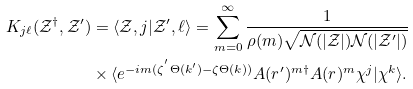<formula> <loc_0><loc_0><loc_500><loc_500>K _ { j \ell } ( \mathcal { Z } ^ { \dagger } , \mathcal { Z } ^ { \prime } ) & = \langle \mathcal { Z } , j | \mathcal { Z } ^ { \prime } , \ell \rangle = \sum _ { m = 0 } ^ { \infty } \frac { 1 } { \rho ( m ) \sqrt { \mathcal { N } ( | \mathcal { Z } | ) \mathcal { N } ( | \mathcal { Z } ^ { \prime } | ) } } \\ & \times \langle e ^ { - i m ( \zeta ^ { ^ { \prime } } \Theta ( k ^ { \prime } ) - \zeta \Theta ( k ) ) } A ( r ^ { \prime } ) ^ { m \dagger } A ( r ) ^ { m } \chi ^ { j } | \chi ^ { k } \rangle .</formula> 